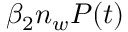Convert formula to latex. <formula><loc_0><loc_0><loc_500><loc_500>\beta _ { 2 } n _ { w } P ( t )</formula> 